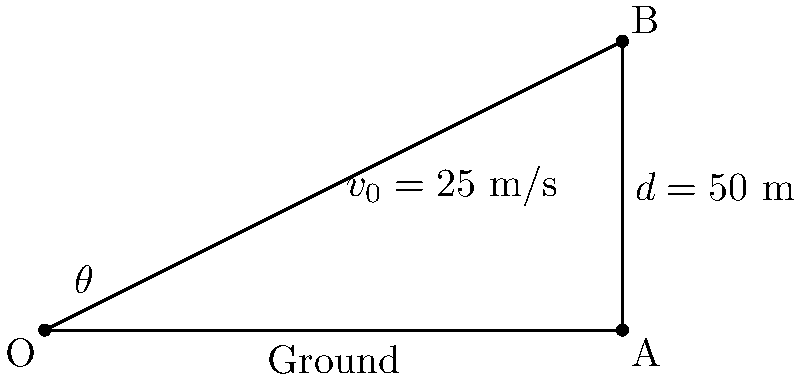In a thrilling match at Balaídos stadium in Vigo, a player attempts a long-range shot. The ball leaves the player's foot at an initial velocity ($v_0$) of 25 m/s and travels a horizontal distance ($d$) of 50 m before hitting the ground. Assuming no air resistance, what is the angle ($\theta$) at which the ball was kicked? (Use $g = 9.8$ m/s² for acceleration due to gravity) Let's approach this step-by-step using the equations of projectile motion:

1) First, we'll use the range equation for projectile motion:
   $d = \frac{v_0^2 \sin(2\theta)}{g}$

2) Rearranging this equation to solve for $\theta$:
   $\sin(2\theta) = \frac{dg}{v_0^2}$

3) Substituting our known values:
   $\sin(2\theta) = \frac{50 \cdot 9.8}{25^2} = 0.784$

4) Taking the inverse sine (arcsin) of both sides:
   $2\theta = \arcsin(0.784)$

5) Solving for $\theta$:
   $\theta = \frac{1}{2} \arcsin(0.784)$

6) Calculate the final result:
   $\theta = 0.5 \cdot 51.68° = 25.84°$

Therefore, the angle at which the ball was kicked is approximately 25.84°.
Answer: $25.84°$ 